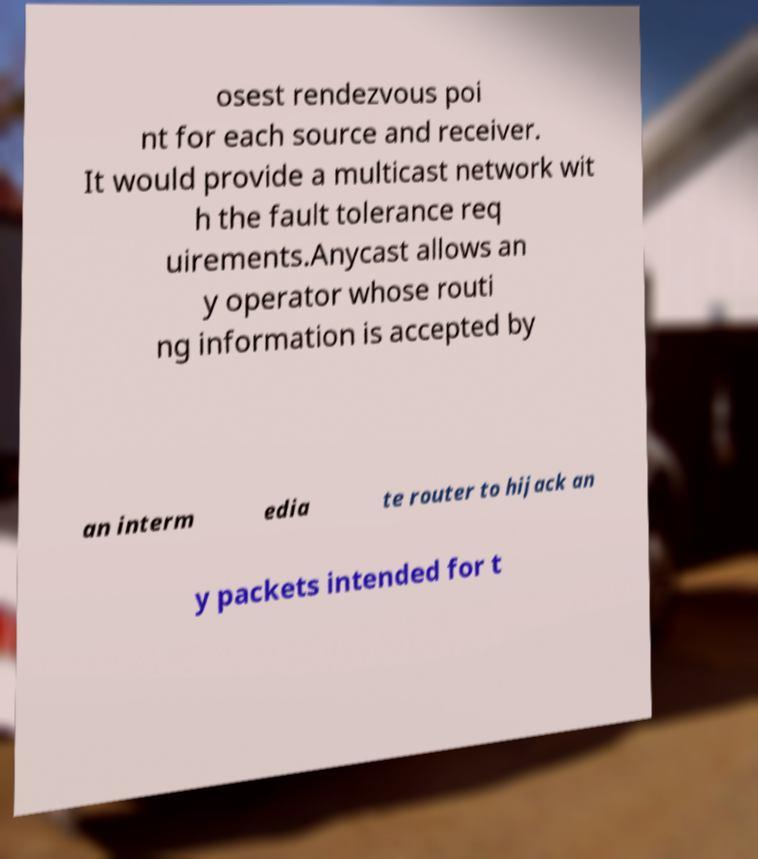Can you accurately transcribe the text from the provided image for me? osest rendezvous poi nt for each source and receiver. It would provide a multicast network wit h the fault tolerance req uirements.Anycast allows an y operator whose routi ng information is accepted by an interm edia te router to hijack an y packets intended for t 